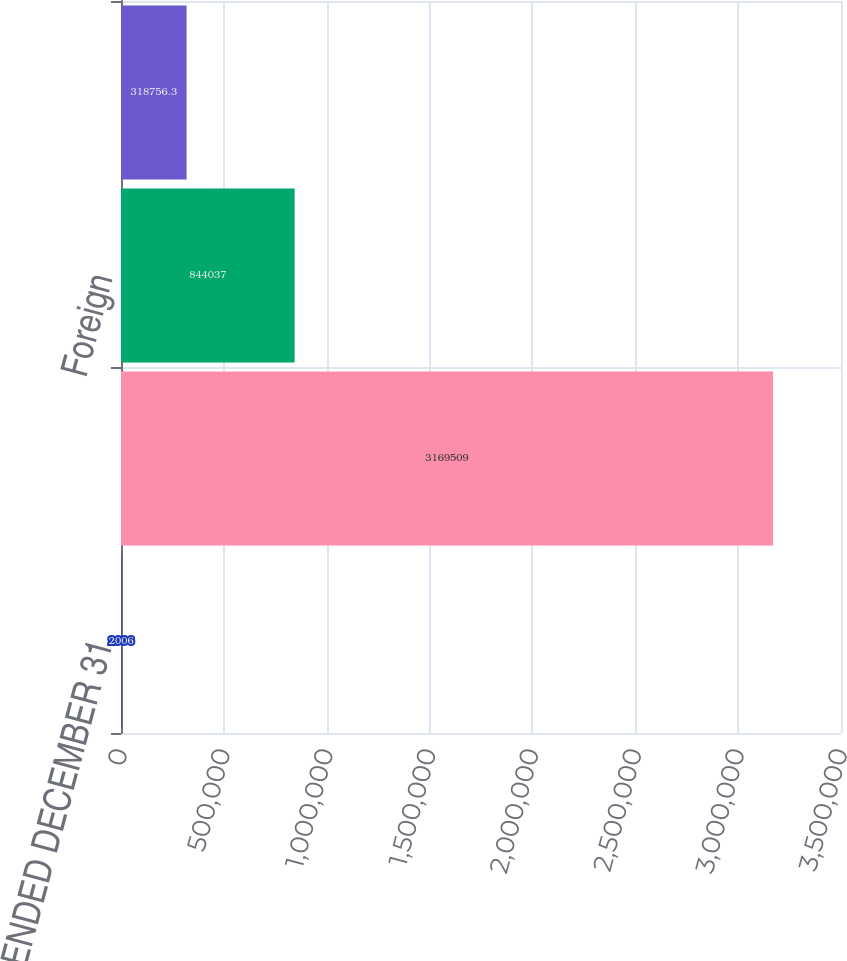<chart> <loc_0><loc_0><loc_500><loc_500><bar_chart><fcel>YEARS ENDED DECEMBER 31<fcel>Domestic<fcel>Foreign<fcel>DECEMBER 31<nl><fcel>2006<fcel>3.16951e+06<fcel>844037<fcel>318756<nl></chart> 